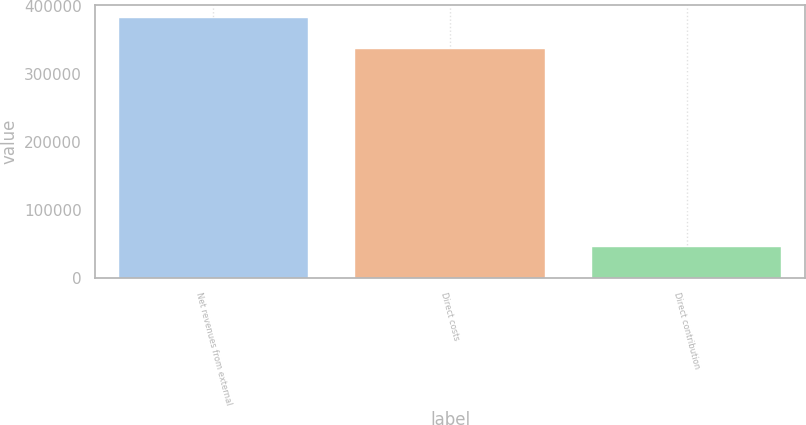<chart> <loc_0><loc_0><loc_500><loc_500><bar_chart><fcel>Net revenues from external<fcel>Direct costs<fcel>Direct contribution<nl><fcel>381822<fcel>337338<fcel>44484<nl></chart> 